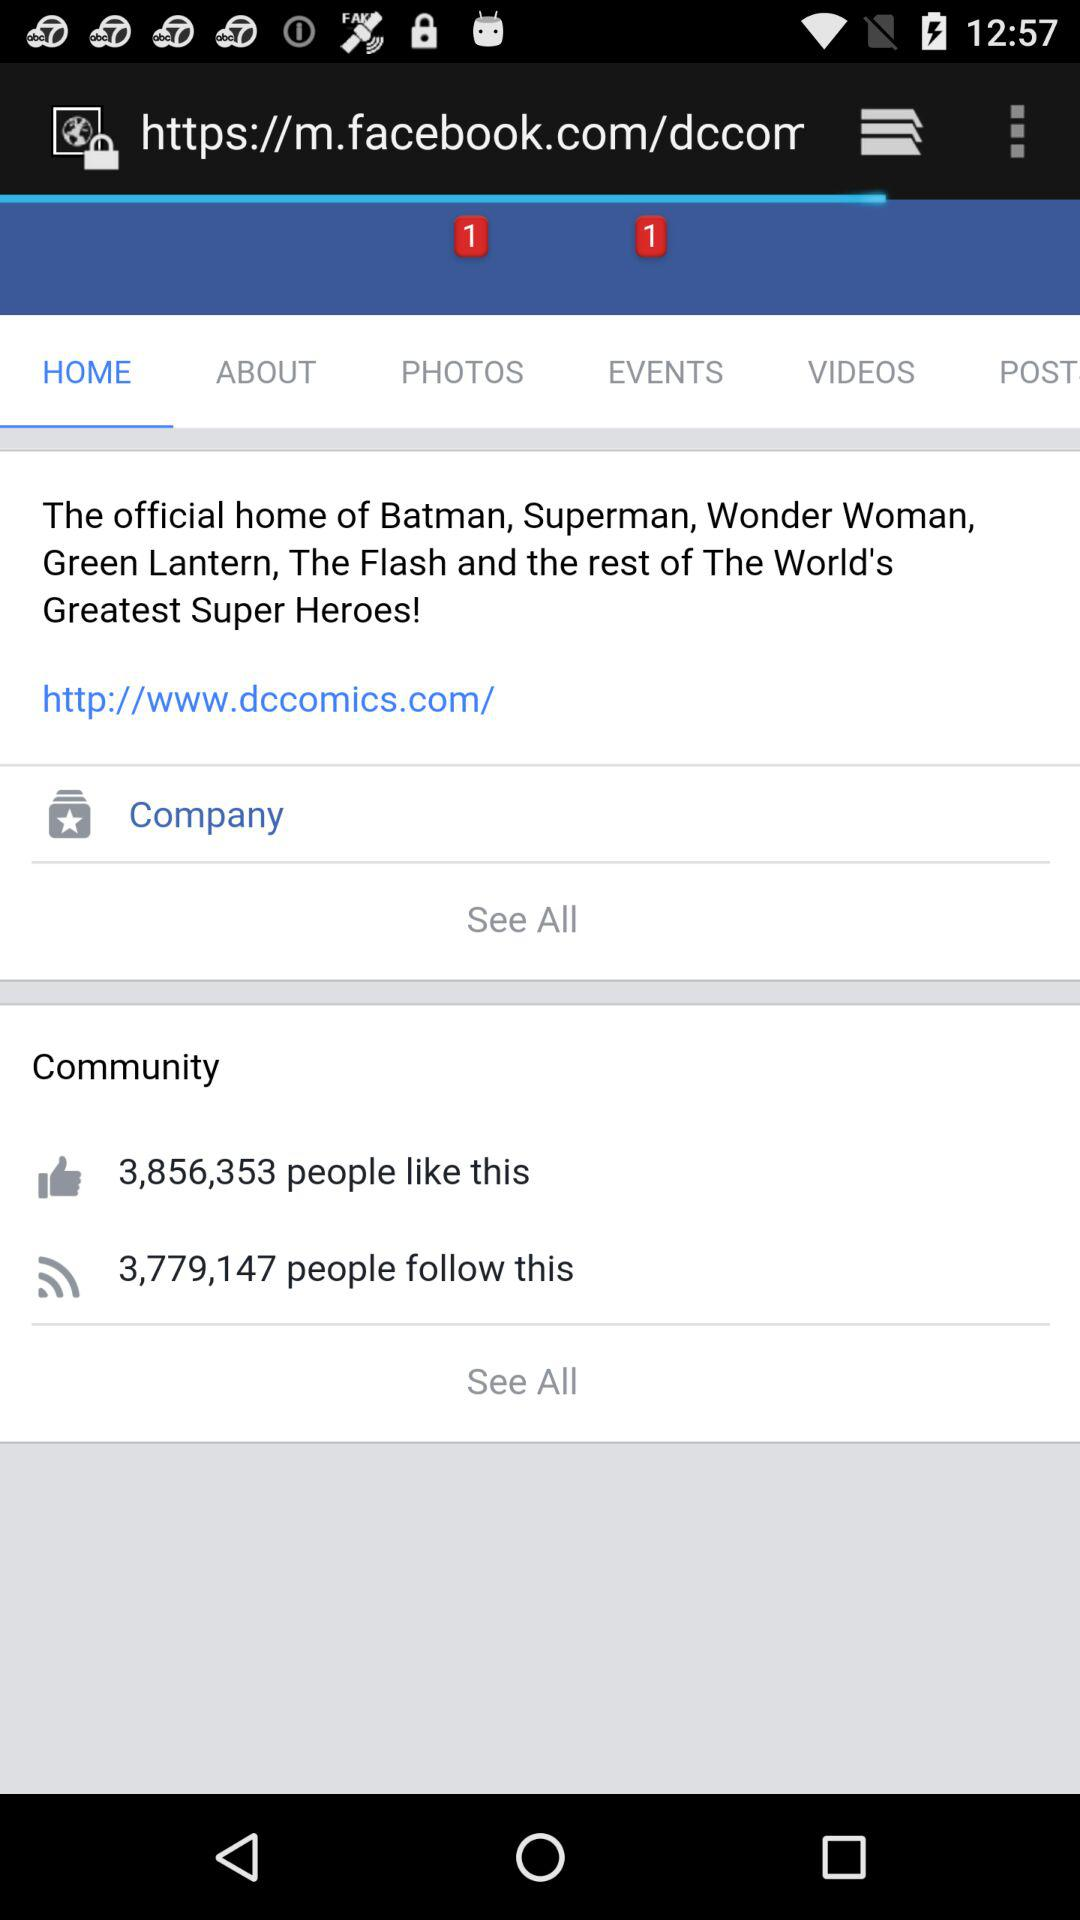How many people like this? The number of people who liked this is 3,856,353. 